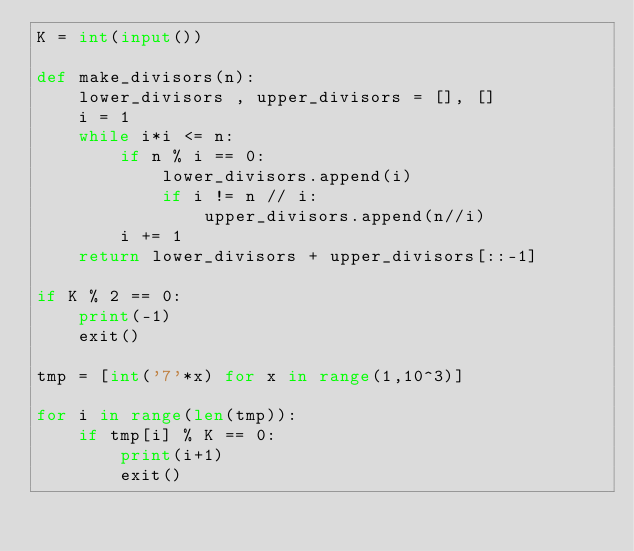<code> <loc_0><loc_0><loc_500><loc_500><_Python_>K = int(input())

def make_divisors(n):
    lower_divisors , upper_divisors = [], []
    i = 1
    while i*i <= n:
        if n % i == 0:
            lower_divisors.append(i)
            if i != n // i:
                upper_divisors.append(n//i)
        i += 1
    return lower_divisors + upper_divisors[::-1]

if K % 2 == 0:
    print(-1)
    exit()

tmp = [int('7'*x) for x in range(1,10^3)]

for i in range(len(tmp)):
    if tmp[i] % K == 0:
        print(i+1)
        exit()
</code> 